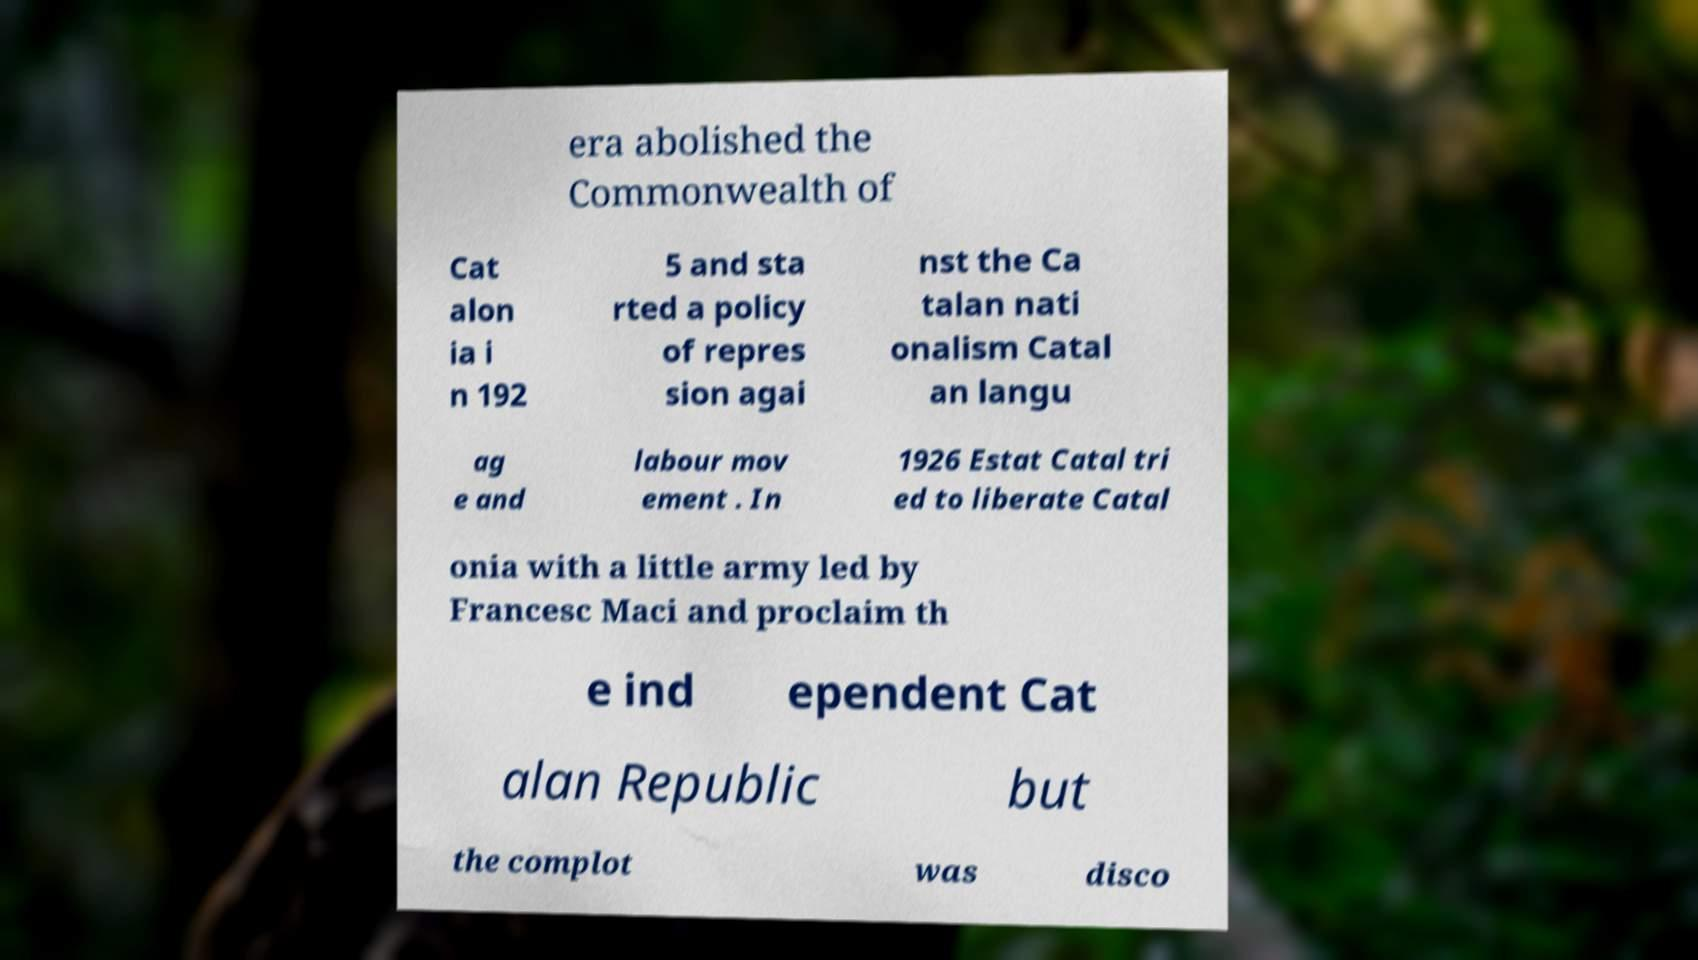Please identify and transcribe the text found in this image. era abolished the Commonwealth of Cat alon ia i n 192 5 and sta rted a policy of repres sion agai nst the Ca talan nati onalism Catal an langu ag e and labour mov ement . In 1926 Estat Catal tri ed to liberate Catal onia with a little army led by Francesc Maci and proclaim th e ind ependent Cat alan Republic but the complot was disco 